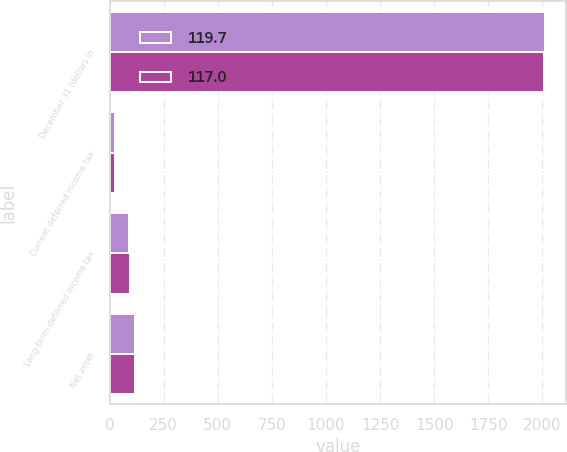Convert chart to OTSL. <chart><loc_0><loc_0><loc_500><loc_500><stacked_bar_chart><ecel><fcel>December 31 (dollars in<fcel>Current deferred income tax<fcel>Long-term deferred income tax<fcel>Net asset<nl><fcel>119.7<fcel>2010<fcel>27.3<fcel>89.7<fcel>117<nl><fcel>117<fcel>2008<fcel>25.8<fcel>93.9<fcel>119.7<nl></chart> 